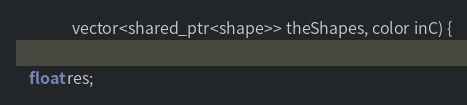Convert code to text. <code><loc_0><loc_0><loc_500><loc_500><_C_>				vector<shared_ptr<shape>> theShapes, color inC) {

	float res;</code> 